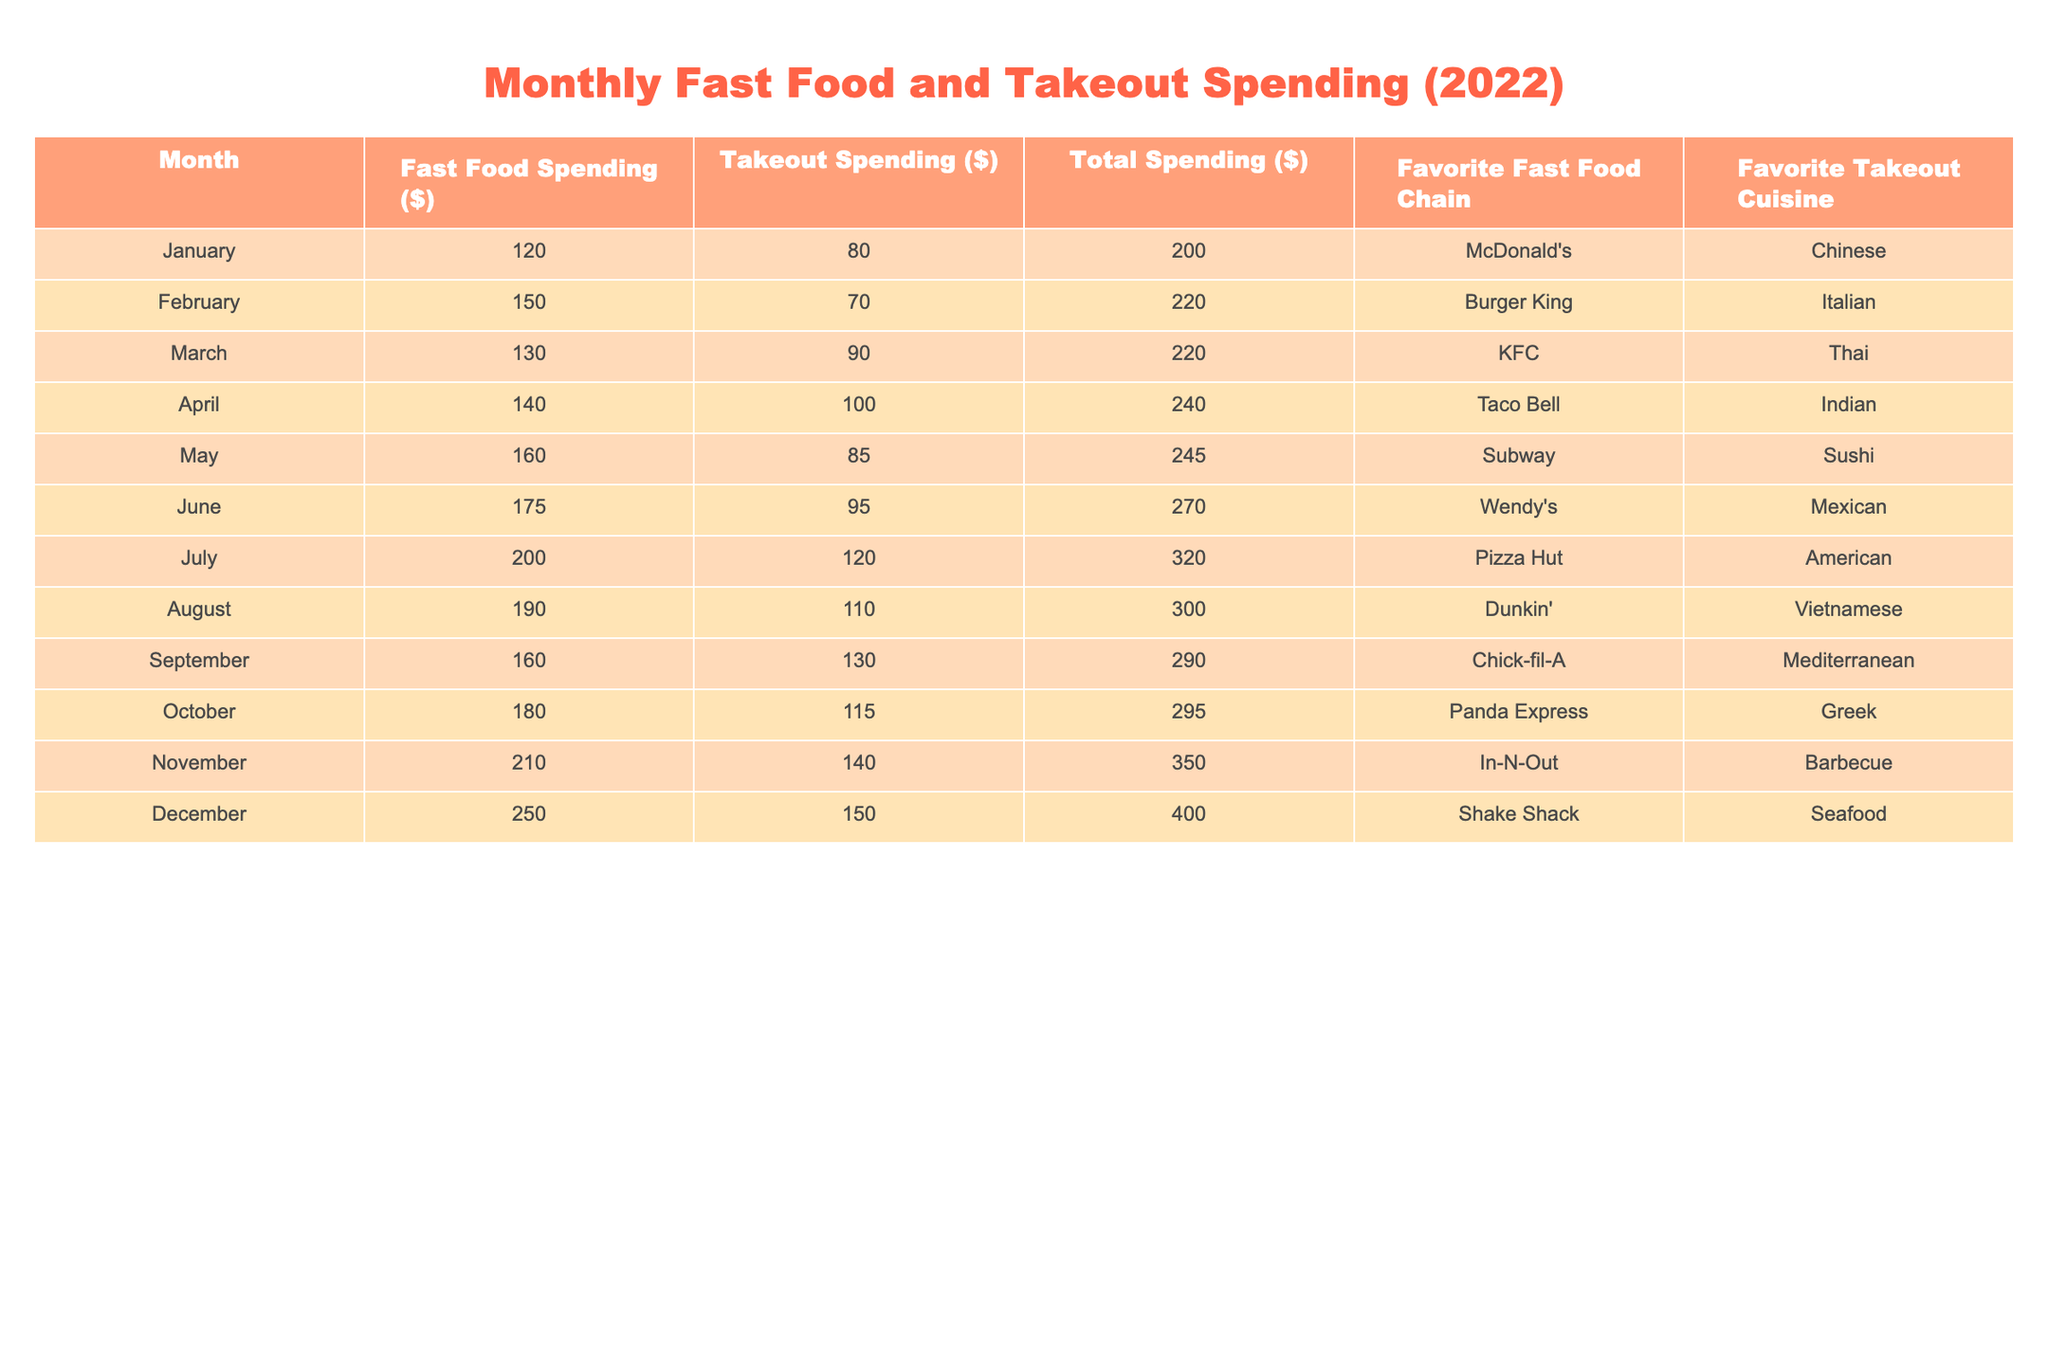What was the total spending on fast food and takeout in November? The table shows that the total spending in November is listed as $350.
Answer: $350 Which month had the highest spending on takeout? By reviewing the spending on takeout for each month, December has the highest spending at $150.
Answer: $150 What was the average fast food spending for the first half of the year (January to June)? The fast food spending for the first six months is $120, $150, $130, $140, $160, and $175. Adding these gives a total of $975, and dividing this by 6 gives an average of $162.50.
Answer: $162.50 Did the spending on fast food exceed $200 in July? The table shows that July's fast food spending was $200, which does not exceed that amount.
Answer: No What was the difference between the total spending in December and January? The total spending in December is $400, and in January, it is $200. The difference is calculated as $400 - $200 = $200.
Answer: $200 Which fast food chain was preferred in the month with the highest total spending? The month with the highest total spending is December at $400, and the preferred fast food chain for that month is Shake Shack.
Answer: Shake Shack What is the total combined spending on fast food and takeout from May to August? The total spending from May to August is $245 (May) + $270 (June) + $320 (July) + $300 (August) = $1135.
Answer: $1135 Was Thai listed as a favorite cuisine for any month? Reviewing the favorite takeout cuisines, Thai is listed as the favorite in March, confirming it was a favorite once.
Answer: Yes Which month saw the least amount spent on fast food? By checking the fast food spending for each month, January shows the least amount spent at $120.
Answer: $120 